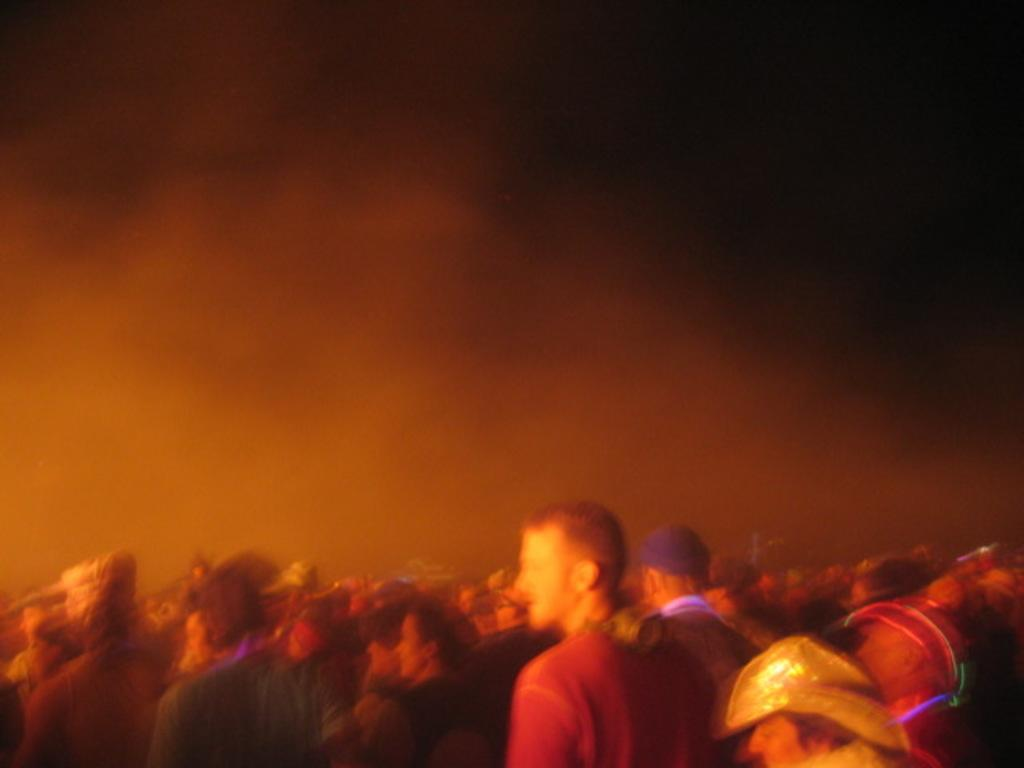What is located at the bottom of the image? There are people standing at the bottom of the image. What natural phenomenon can be seen in the middle of the image? There is fog visible in the middle of the image. What type of regret can be seen on the stage in the image? There is no stage present in the image, and therefore no such activity or emotion can be observed. 